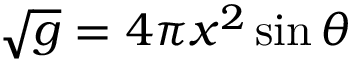<formula> <loc_0><loc_0><loc_500><loc_500>\sqrt { g } = 4 \pi x ^ { 2 } \sin \theta</formula> 